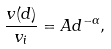Convert formula to latex. <formula><loc_0><loc_0><loc_500><loc_500>\frac { v ( d ) } { v _ { i } } = A d ^ { - \alpha } ,</formula> 